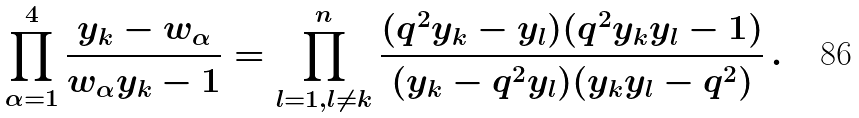<formula> <loc_0><loc_0><loc_500><loc_500>\prod _ { \alpha = 1 } ^ { 4 } \frac { y _ { k } - w _ { \alpha } } { w _ { \alpha } y _ { k } - 1 } = \prod _ { l = 1 , l \ne k } ^ { n } \frac { ( q ^ { 2 } y _ { k } - y _ { l } ) ( q ^ { 2 } y _ { k } y _ { l } - 1 ) } { ( y _ { k } - q ^ { 2 } y _ { l } ) ( y _ { k } y _ { l } - q ^ { 2 } ) } \, .</formula> 